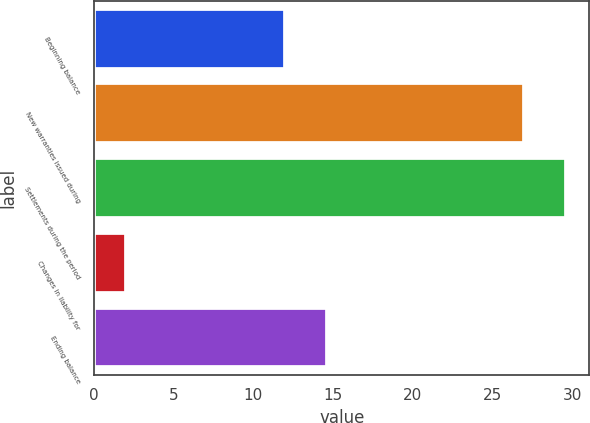Convert chart. <chart><loc_0><loc_0><loc_500><loc_500><bar_chart><fcel>Beginning balance<fcel>New warranties issued during<fcel>Settlements during the period<fcel>Changes in liability for<fcel>Ending balance<nl><fcel>12<fcel>27<fcel>29.6<fcel>2<fcel>14.6<nl></chart> 